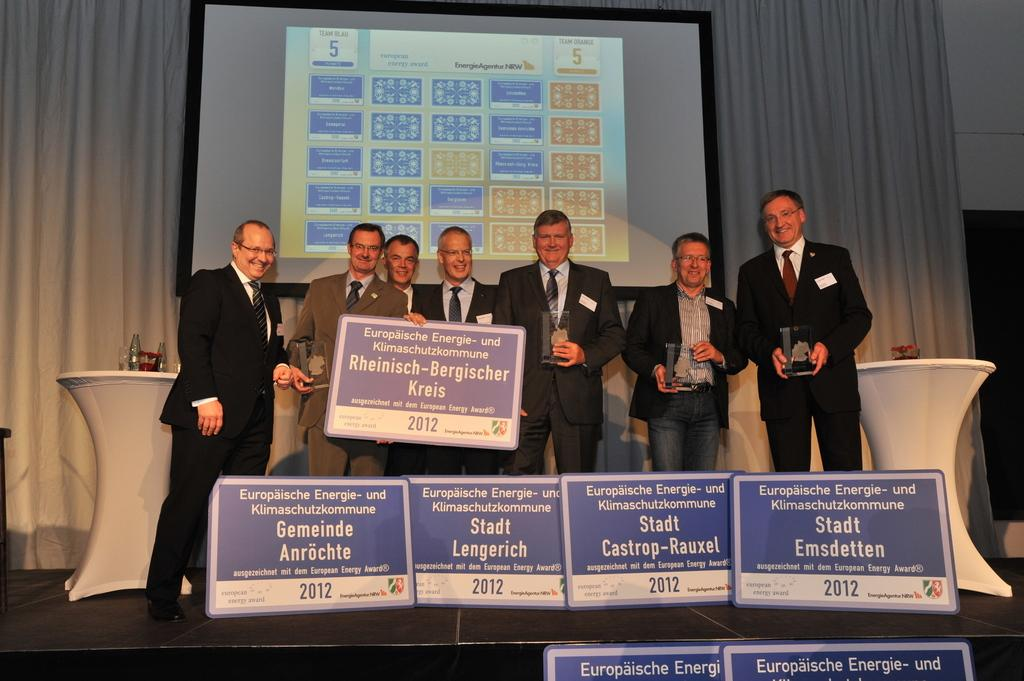What can be seen in the foreground of the image? In the foreground of the image, there are posters, people holding a poster, and trophies. What is the purpose of the people holding the poster? It is not clear from the image what the purpose of the people holding the poster is, but they are likely displaying or promoting something. What is present in the background of the image? In the background of the image, there are tables, a screen, a curtain, and other objects. What might the screen be used for in the image? The screen in the background could be used for displaying information, showing a presentation, or playing a video. What type of stamp can be seen on the trophies in the image? There are no stamps visible on the trophies in the image. What book is the achiever reading in the image? There is no achiever or book present in the image. 